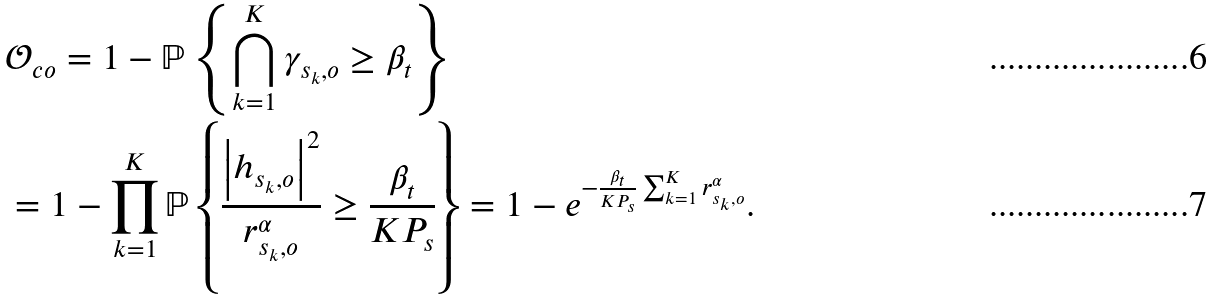Convert formula to latex. <formula><loc_0><loc_0><loc_500><loc_500>& \mathcal { O } _ { c o } = 1 - \mathbb { P } \left \{ \bigcap ^ { K } _ { k = 1 } \gamma _ { s _ { k } , o } \geq \beta _ { t } \right \} \\ & = 1 - \prod _ { k = 1 } ^ { K } \mathbb { P } \left \{ \frac { \left | h _ { s _ { k } , o } \right | ^ { 2 } } { r _ { s _ { k } , o } ^ { \alpha } } \geq \frac { \beta _ { t } } { K P _ { s } } \right \} = 1 - e ^ { - \frac { \beta _ { t } } { K P _ { s } } \sum _ { k = 1 } ^ { K } r _ { s _ { k } , o } ^ { \alpha } } .</formula> 